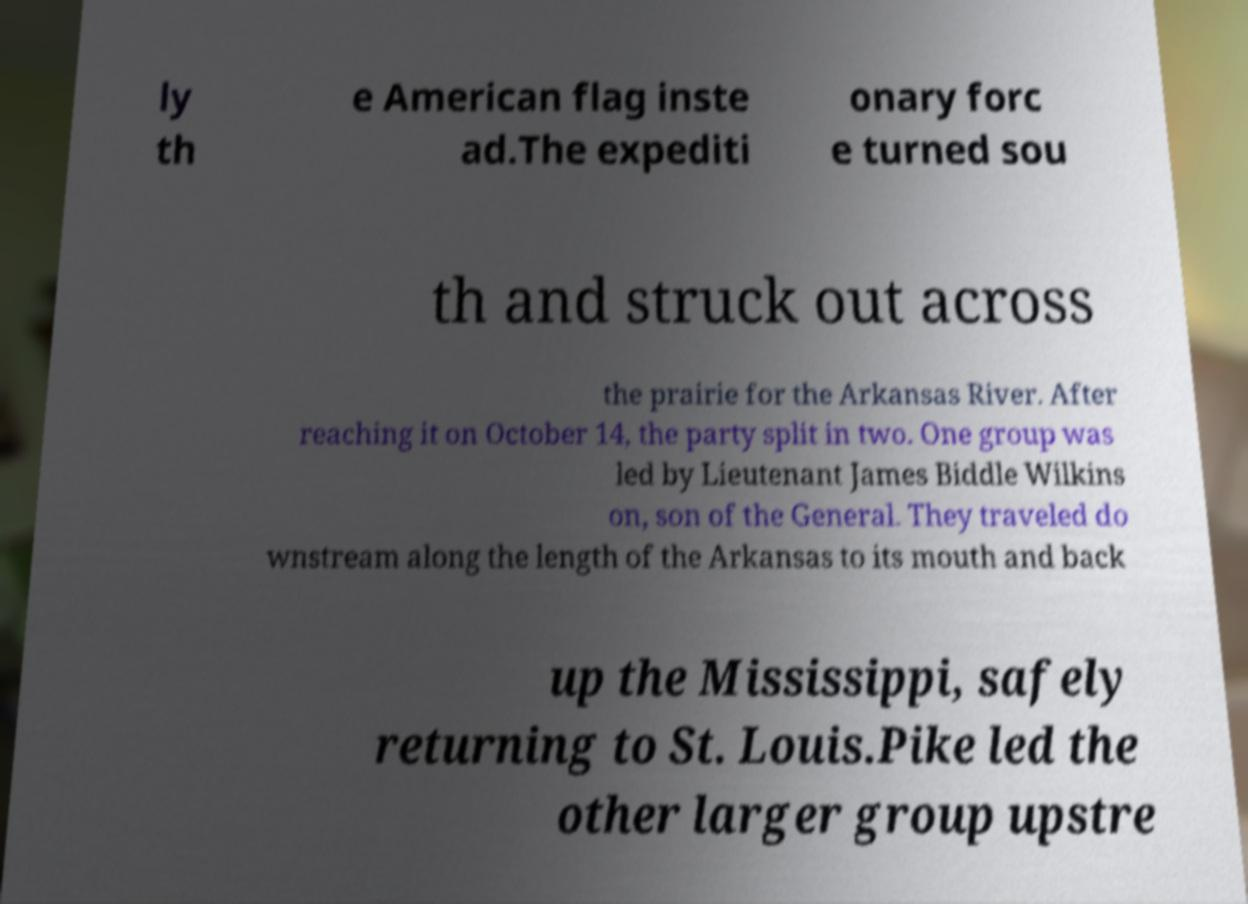Could you extract and type out the text from this image? ly th e American flag inste ad.The expediti onary forc e turned sou th and struck out across the prairie for the Arkansas River. After reaching it on October 14, the party split in two. One group was led by Lieutenant James Biddle Wilkins on, son of the General. They traveled do wnstream along the length of the Arkansas to its mouth and back up the Mississippi, safely returning to St. Louis.Pike led the other larger group upstre 